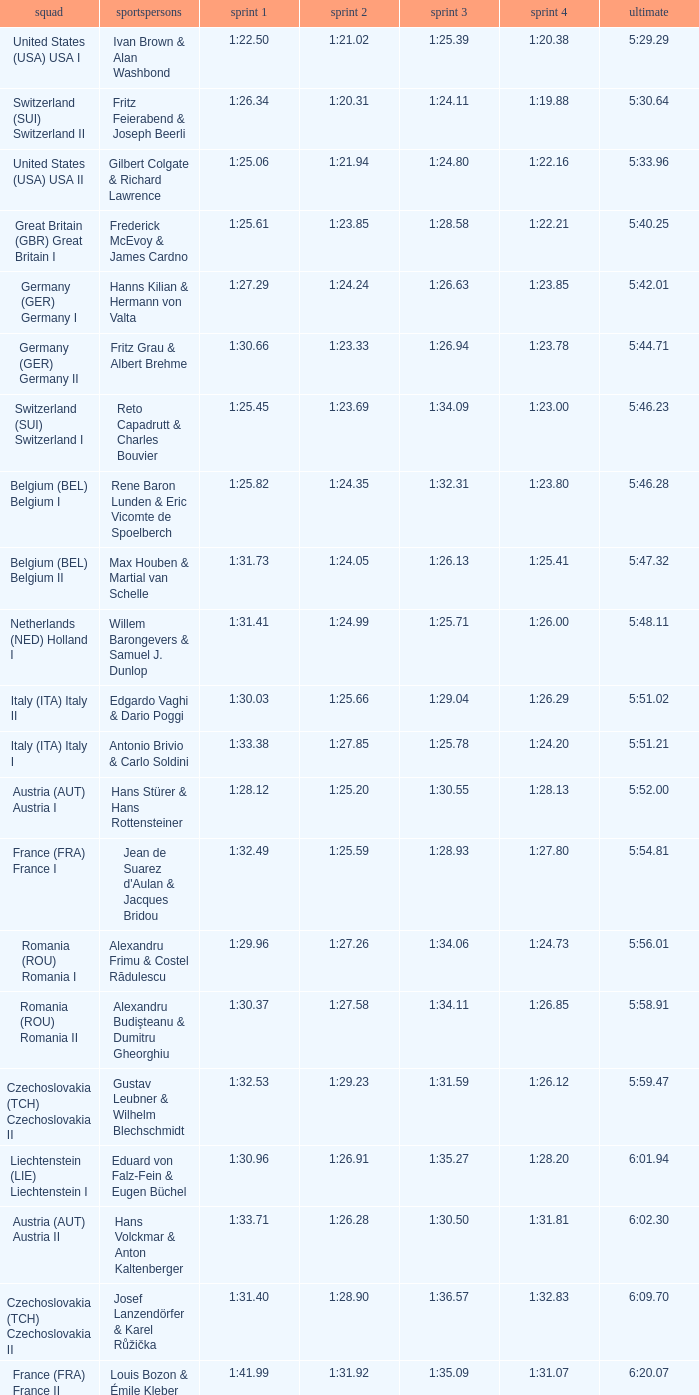Which Final has a Team of liechtenstein (lie) liechtenstein i? 6:01.94. 